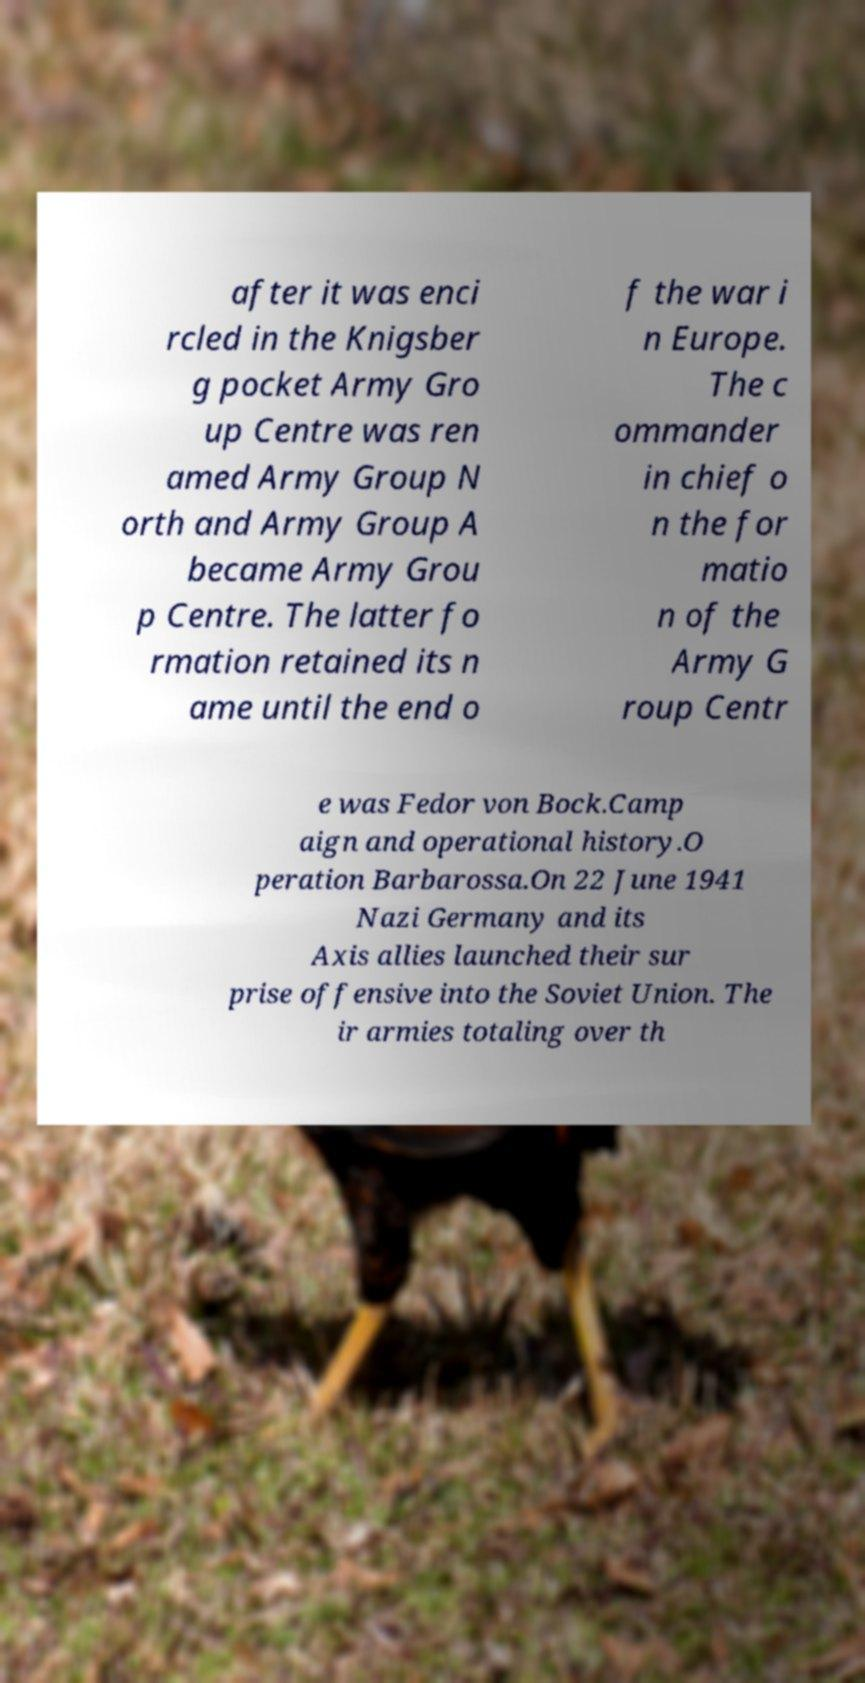There's text embedded in this image that I need extracted. Can you transcribe it verbatim? after it was enci rcled in the Knigsber g pocket Army Gro up Centre was ren amed Army Group N orth and Army Group A became Army Grou p Centre. The latter fo rmation retained its n ame until the end o f the war i n Europe. The c ommander in chief o n the for matio n of the Army G roup Centr e was Fedor von Bock.Camp aign and operational history.O peration Barbarossa.On 22 June 1941 Nazi Germany and its Axis allies launched their sur prise offensive into the Soviet Union. The ir armies totaling over th 